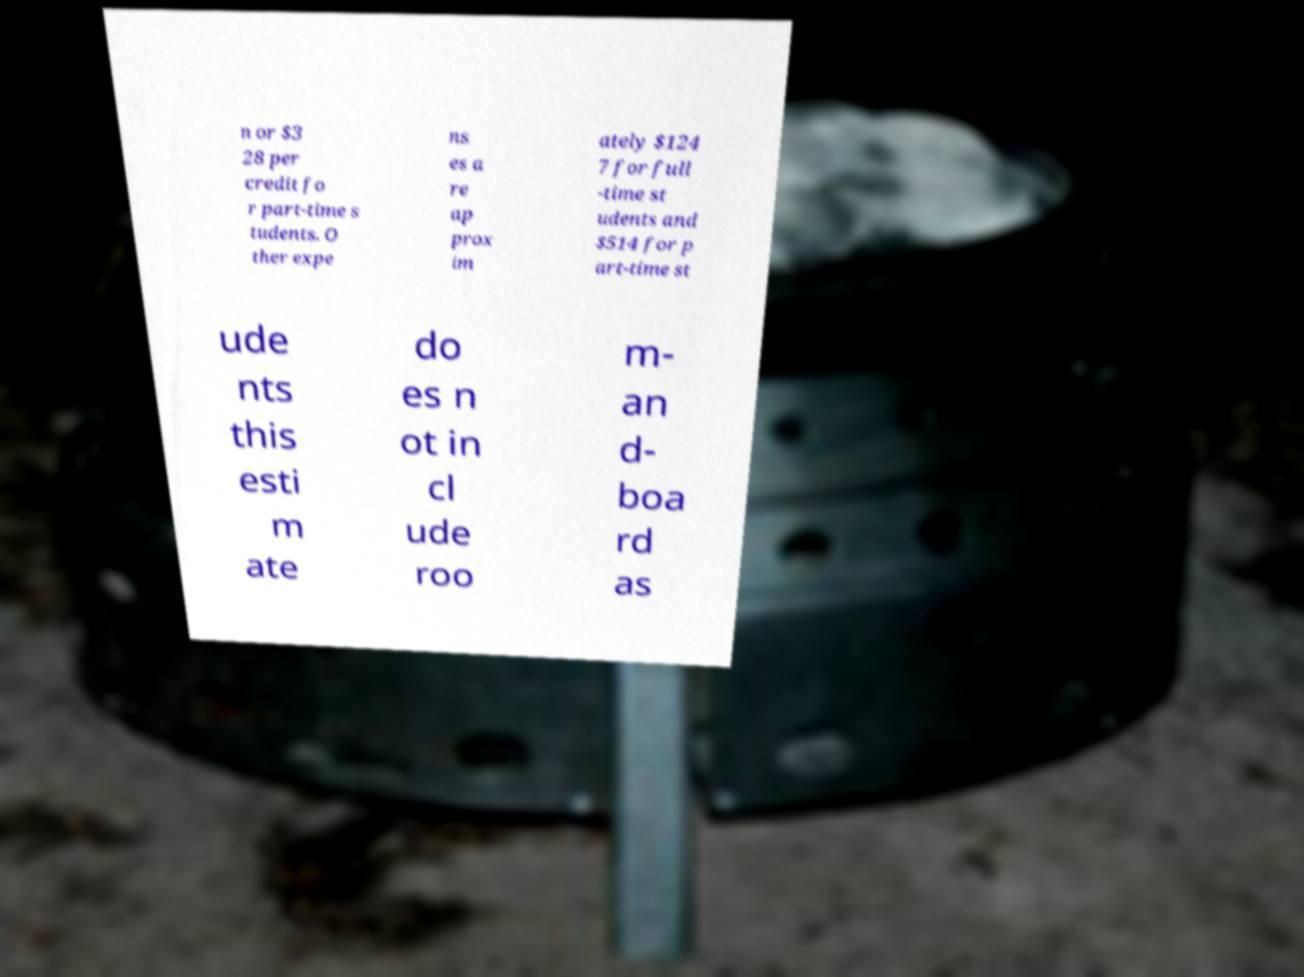What messages or text are displayed in this image? I need them in a readable, typed format. n or $3 28 per credit fo r part-time s tudents. O ther expe ns es a re ap prox im ately $124 7 for full -time st udents and $514 for p art-time st ude nts this esti m ate do es n ot in cl ude roo m- an d- boa rd as 